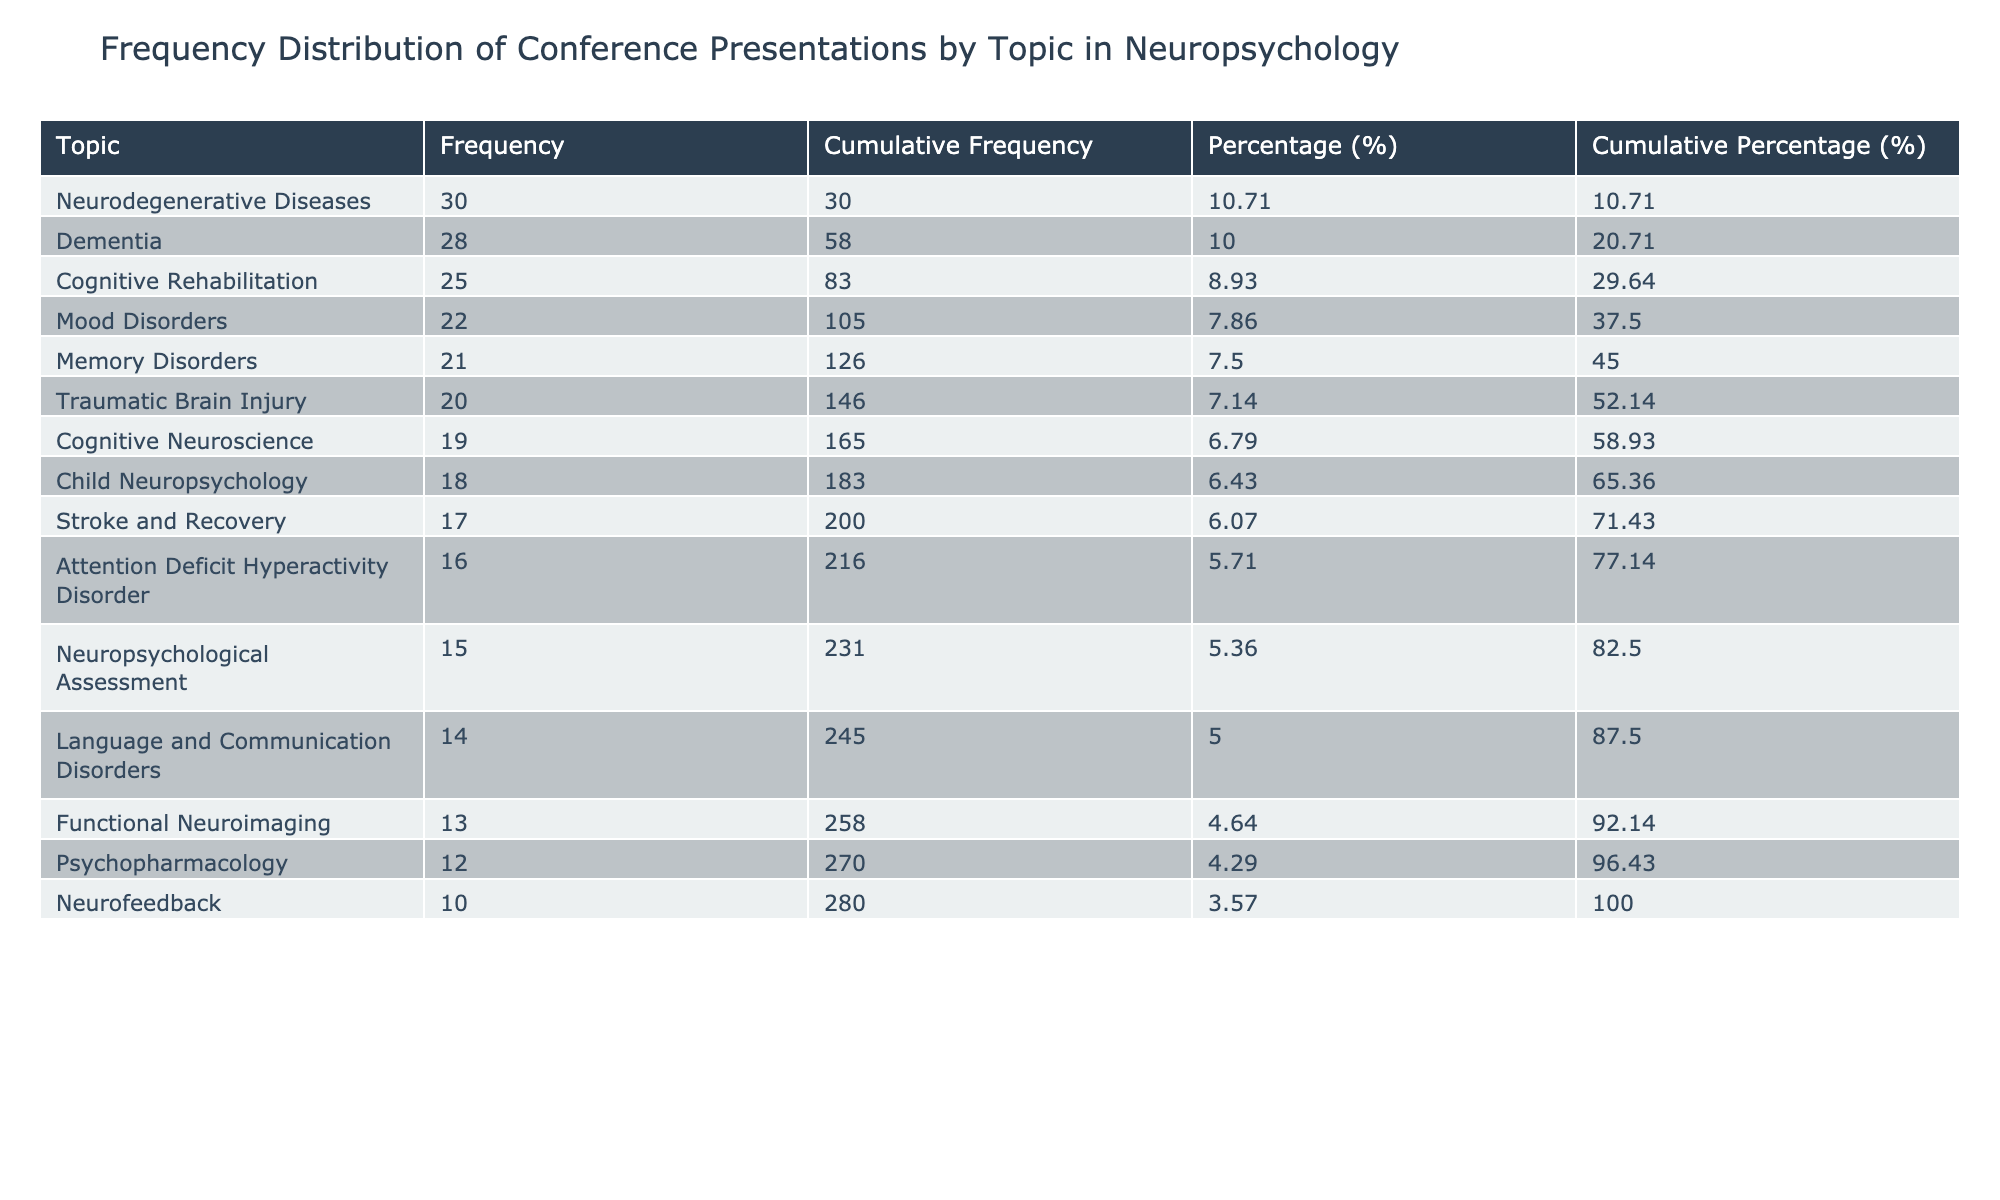What topic has the highest number of conference presentations? By looking at the sorted table, I can see that "Neurodegenerative Diseases" has the highest number of conference presentations, totaling 30.
Answer: Neurodegenerative Diseases How many conference presentations were made on Cognitive Rehabilitation? The table shows that "Cognitive Rehabilitation" has 25 conference presentations listed.
Answer: 25 What is the cumulative frequency of presentations for Mood Disorders? For "Mood Disorders," I check the table and find its individual frequency is 22. I also look at previous topics, namely Cognitive Rehabilitation and Neurodegenerative Diseases, which combine for 55. Therefore, the cumulative frequency for Mood Disorders is 55 + 22 = 77.
Answer: 77 Is there a topic with fewer than 15 conference presentations? Looking through the table, I see that "Neurofeedback" has only 10 conference presentations. Therefore, there is indeed a topic with fewer than 15 presentations.
Answer: Yes What is the percentage of presentations for Traumatic Brain Injury compared to the total? First, I find the total number of presentations, which is 300. "Traumatic Brain Injury" has 20 presentations. The percentage is calculated as (20 / 300) * 100 = 6.67.
Answer: 6.67 Which topic has the least number of conference presentations, and how many were there? The table lists "Neurofeedback" as the topic with the least frequency, having 10 conference presentations.
Answer: Neurofeedback, 10 What is the difference in conference presentations between Dementia and Memory Disorders? Dementia has 28 presentations and Memory Disorders has 21. To find the difference, I subtract 21 from 28 resulting in 7.
Answer: 7 What is the average number of presentations for the top three topics? The top three topics are Neurodegenerative Diseases (30), Dementia (28), and Cognitive Rehabilitation (25). To find the average, I first sum these values giving total = 30 + 28 + 25 = 83, then divide by 3. Therefore, 83 / 3 = approximately 27.67.
Answer: 27.67 How many topics have more than 20 conference presentations? Looking at the table, the topics with more than 20 presentations are Neurodegenerative Diseases, Dementia, Cognitive Rehabilitation, Mood Disorders, and Memory Disorders. In total, that is 5 topics.
Answer: 5 